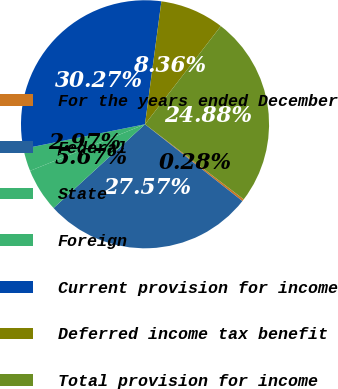Convert chart. <chart><loc_0><loc_0><loc_500><loc_500><pie_chart><fcel>For the years ended December<fcel>Federal<fcel>State<fcel>Foreign<fcel>Current provision for income<fcel>Deferred income tax benefit<fcel>Total provision for income<nl><fcel>0.28%<fcel>27.57%<fcel>5.67%<fcel>2.97%<fcel>30.27%<fcel>8.36%<fcel>24.88%<nl></chart> 